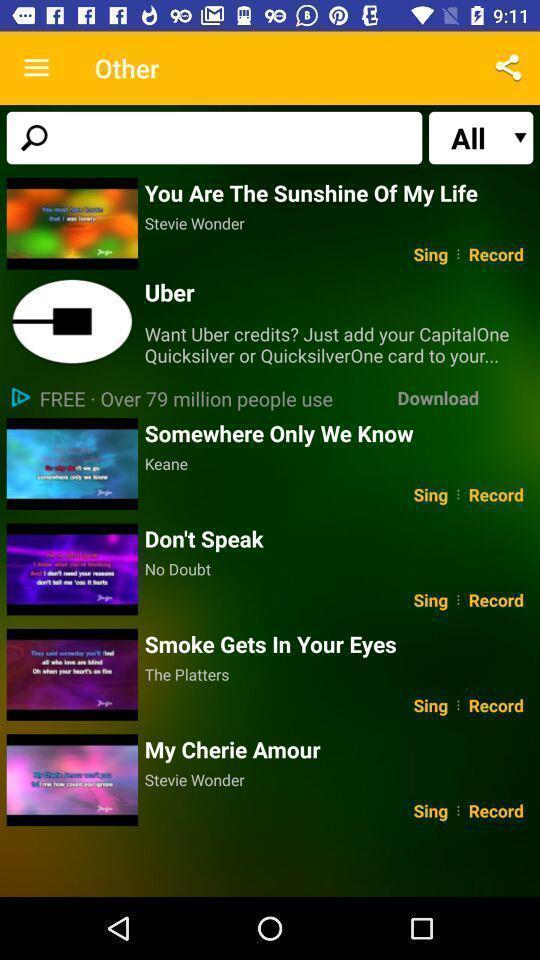Explain the elements present in this screenshot. Page showing search bar to find different songs. 